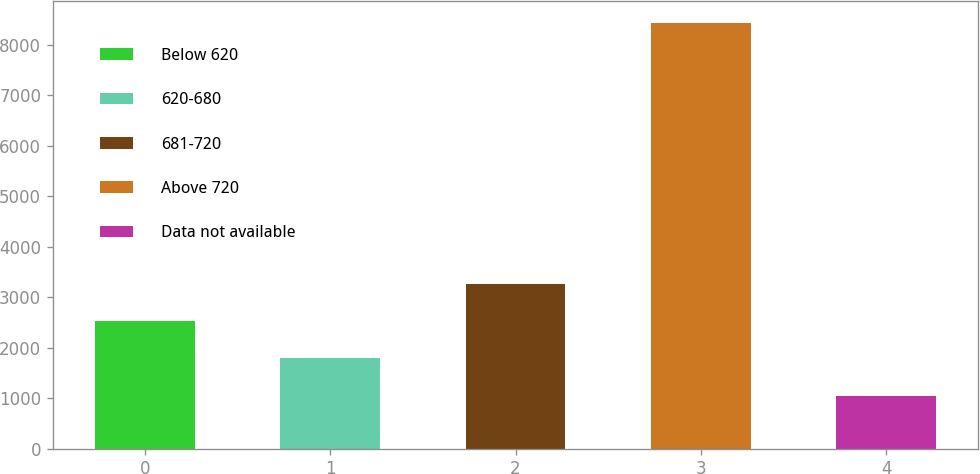Convert chart. <chart><loc_0><loc_0><loc_500><loc_500><bar_chart><fcel>Below 620<fcel>620-680<fcel>681-720<fcel>Above 720<fcel>Data not available<nl><fcel>2529<fcel>1790<fcel>3268<fcel>8441<fcel>1051<nl></chart> 